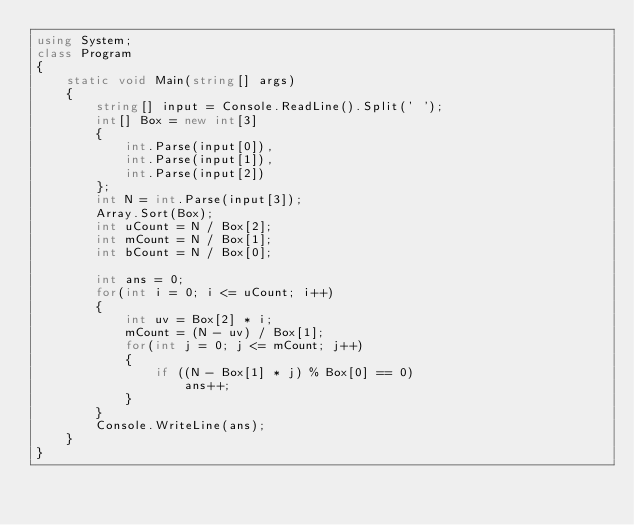Convert code to text. <code><loc_0><loc_0><loc_500><loc_500><_C#_>using System;
class Program
{
    static void Main(string[] args)
    {
        string[] input = Console.ReadLine().Split(' ');
        int[] Box = new int[3]
        {
            int.Parse(input[0]),
            int.Parse(input[1]),
            int.Parse(input[2])
        };
        int N = int.Parse(input[3]);
        Array.Sort(Box);
        int uCount = N / Box[2];
        int mCount = N / Box[1];
        int bCount = N / Box[0];

        int ans = 0;
        for(int i = 0; i <= uCount; i++)
        {
            int uv = Box[2] * i;
            mCount = (N - uv) / Box[1];
            for(int j = 0; j <= mCount; j++)
            {
                if ((N - Box[1] * j) % Box[0] == 0)
                    ans++;
            }
        }
        Console.WriteLine(ans);
    }
}</code> 